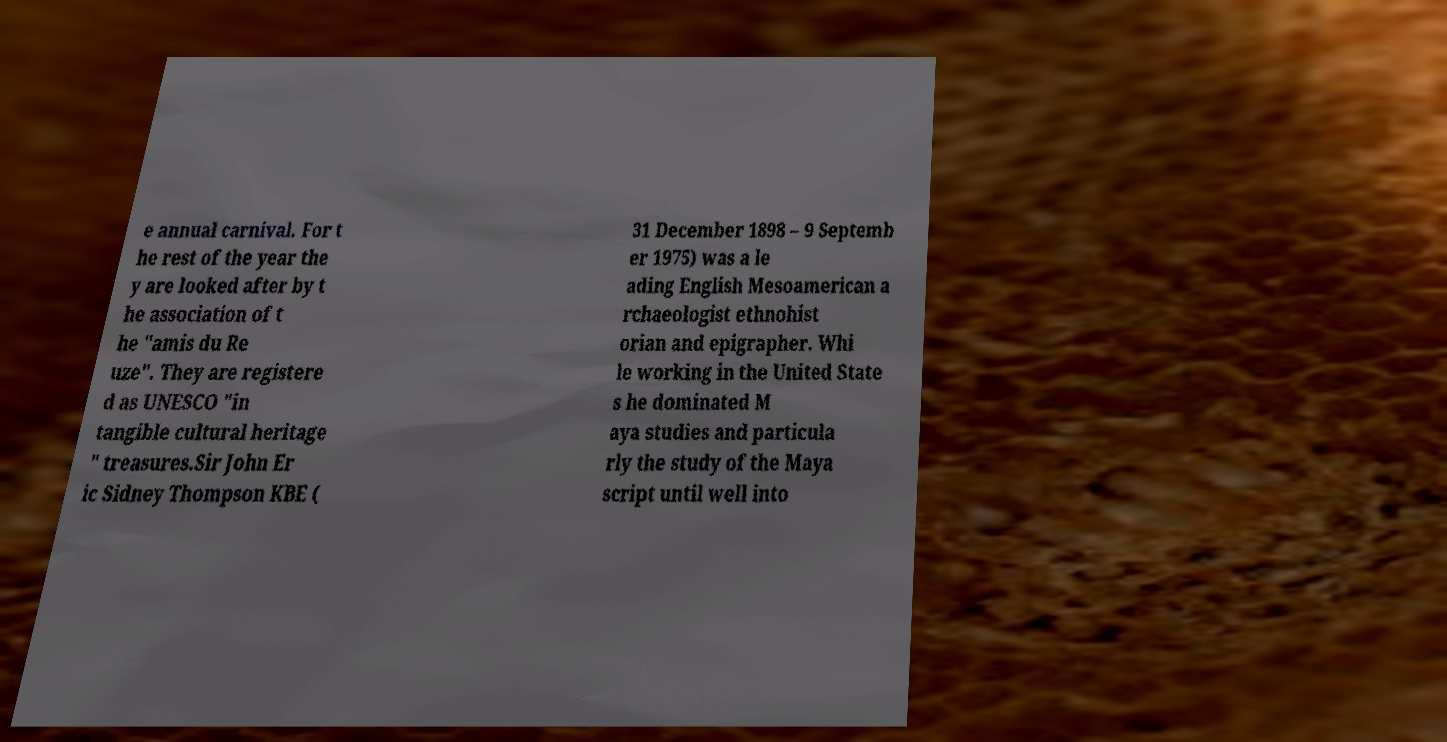For documentation purposes, I need the text within this image transcribed. Could you provide that? e annual carnival. For t he rest of the year the y are looked after by t he association of t he "amis du Re uze". They are registere d as UNESCO "in tangible cultural heritage " treasures.Sir John Er ic Sidney Thompson KBE ( 31 December 1898 – 9 Septemb er 1975) was a le ading English Mesoamerican a rchaeologist ethnohist orian and epigrapher. Whi le working in the United State s he dominated M aya studies and particula rly the study of the Maya script until well into 